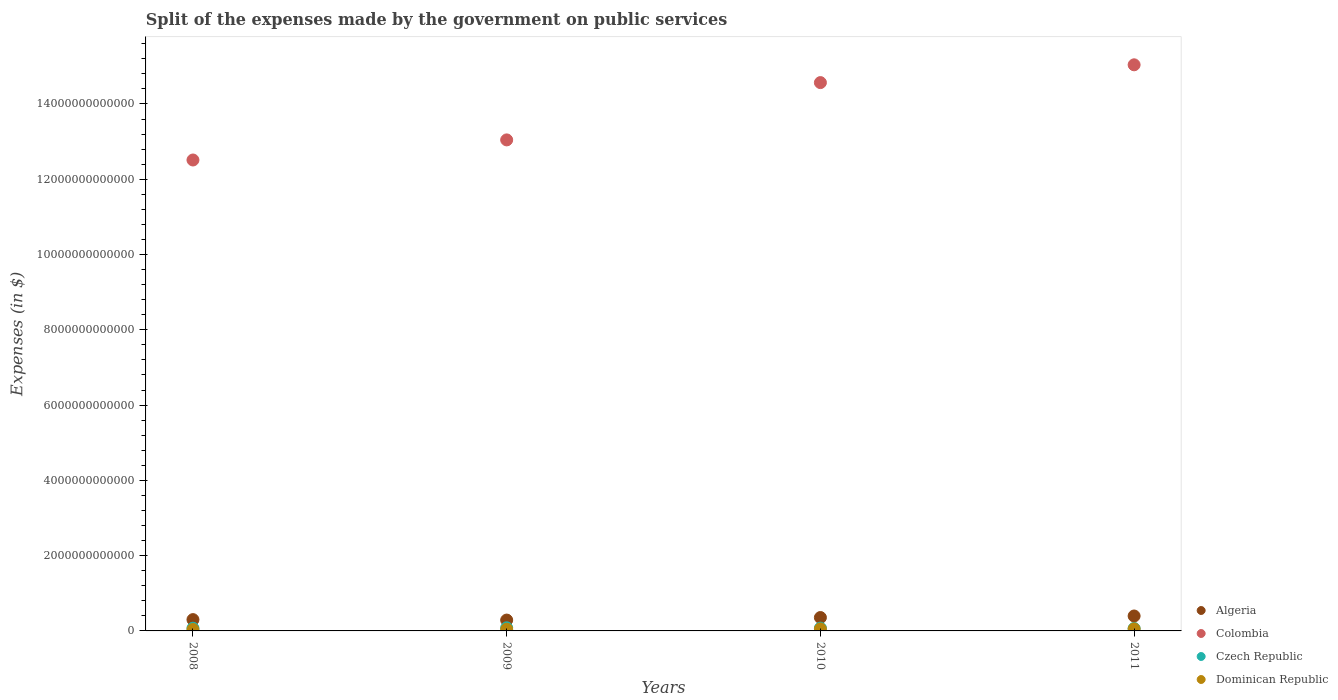How many different coloured dotlines are there?
Make the answer very short. 4. What is the expenses made by the government on public services in Dominican Republic in 2011?
Your answer should be compact. 5.39e+1. Across all years, what is the maximum expenses made by the government on public services in Algeria?
Your answer should be compact. 3.97e+11. Across all years, what is the minimum expenses made by the government on public services in Czech Republic?
Make the answer very short. 6.49e+1. What is the total expenses made by the government on public services in Czech Republic in the graph?
Offer a terse response. 2.95e+11. What is the difference between the expenses made by the government on public services in Colombia in 2008 and that in 2010?
Offer a terse response. -2.06e+12. What is the difference between the expenses made by the government on public services in Algeria in 2011 and the expenses made by the government on public services in Dominican Republic in 2010?
Provide a short and direct response. 3.44e+11. What is the average expenses made by the government on public services in Colombia per year?
Your answer should be compact. 1.38e+13. In the year 2009, what is the difference between the expenses made by the government on public services in Algeria and expenses made by the government on public services in Czech Republic?
Provide a succinct answer. 2.05e+11. What is the ratio of the expenses made by the government on public services in Colombia in 2009 to that in 2010?
Give a very brief answer. 0.9. What is the difference between the highest and the second highest expenses made by the government on public services in Algeria?
Your answer should be very brief. 4.10e+1. What is the difference between the highest and the lowest expenses made by the government on public services in Dominican Republic?
Offer a terse response. 1.66e+1. In how many years, is the expenses made by the government on public services in Colombia greater than the average expenses made by the government on public services in Colombia taken over all years?
Provide a succinct answer. 2. Is the sum of the expenses made by the government on public services in Algeria in 2008 and 2009 greater than the maximum expenses made by the government on public services in Colombia across all years?
Your answer should be very brief. No. Is it the case that in every year, the sum of the expenses made by the government on public services in Algeria and expenses made by the government on public services in Czech Republic  is greater than the sum of expenses made by the government on public services in Colombia and expenses made by the government on public services in Dominican Republic?
Offer a terse response. Yes. Is it the case that in every year, the sum of the expenses made by the government on public services in Dominican Republic and expenses made by the government on public services in Algeria  is greater than the expenses made by the government on public services in Colombia?
Ensure brevity in your answer.  No. Is the expenses made by the government on public services in Czech Republic strictly less than the expenses made by the government on public services in Dominican Republic over the years?
Your answer should be very brief. No. How many dotlines are there?
Your answer should be compact. 4. How many years are there in the graph?
Make the answer very short. 4. What is the difference between two consecutive major ticks on the Y-axis?
Your answer should be very brief. 2.00e+12. Does the graph contain grids?
Provide a short and direct response. No. How are the legend labels stacked?
Make the answer very short. Vertical. What is the title of the graph?
Give a very brief answer. Split of the expenses made by the government on public services. What is the label or title of the X-axis?
Offer a terse response. Years. What is the label or title of the Y-axis?
Provide a short and direct response. Expenses (in $). What is the Expenses (in $) in Algeria in 2008?
Your answer should be compact. 3.00e+11. What is the Expenses (in $) in Colombia in 2008?
Offer a terse response. 1.25e+13. What is the Expenses (in $) in Czech Republic in 2008?
Offer a terse response. 7.24e+1. What is the Expenses (in $) of Dominican Republic in 2008?
Offer a very short reply. 3.73e+1. What is the Expenses (in $) of Algeria in 2009?
Provide a succinct answer. 2.88e+11. What is the Expenses (in $) in Colombia in 2009?
Provide a succinct answer. 1.30e+13. What is the Expenses (in $) in Czech Republic in 2009?
Give a very brief answer. 8.32e+1. What is the Expenses (in $) of Dominican Republic in 2009?
Offer a very short reply. 4.52e+1. What is the Expenses (in $) in Algeria in 2010?
Offer a very short reply. 3.56e+11. What is the Expenses (in $) of Colombia in 2010?
Make the answer very short. 1.46e+13. What is the Expenses (in $) in Czech Republic in 2010?
Offer a terse response. 7.45e+1. What is the Expenses (in $) of Dominican Republic in 2010?
Provide a short and direct response. 5.28e+1. What is the Expenses (in $) in Algeria in 2011?
Offer a very short reply. 3.97e+11. What is the Expenses (in $) of Colombia in 2011?
Make the answer very short. 1.50e+13. What is the Expenses (in $) of Czech Republic in 2011?
Your answer should be very brief. 6.49e+1. What is the Expenses (in $) of Dominican Republic in 2011?
Make the answer very short. 5.39e+1. Across all years, what is the maximum Expenses (in $) in Algeria?
Offer a very short reply. 3.97e+11. Across all years, what is the maximum Expenses (in $) of Colombia?
Provide a short and direct response. 1.50e+13. Across all years, what is the maximum Expenses (in $) in Czech Republic?
Provide a short and direct response. 8.32e+1. Across all years, what is the maximum Expenses (in $) of Dominican Republic?
Provide a succinct answer. 5.39e+1. Across all years, what is the minimum Expenses (in $) of Algeria?
Your answer should be very brief. 2.88e+11. Across all years, what is the minimum Expenses (in $) of Colombia?
Ensure brevity in your answer.  1.25e+13. Across all years, what is the minimum Expenses (in $) in Czech Republic?
Make the answer very short. 6.49e+1. Across all years, what is the minimum Expenses (in $) in Dominican Republic?
Provide a short and direct response. 3.73e+1. What is the total Expenses (in $) in Algeria in the graph?
Provide a succinct answer. 1.34e+12. What is the total Expenses (in $) of Colombia in the graph?
Offer a very short reply. 5.52e+13. What is the total Expenses (in $) of Czech Republic in the graph?
Offer a very short reply. 2.95e+11. What is the total Expenses (in $) of Dominican Republic in the graph?
Make the answer very short. 1.89e+11. What is the difference between the Expenses (in $) of Algeria in 2008 and that in 2009?
Your response must be concise. 1.22e+1. What is the difference between the Expenses (in $) in Colombia in 2008 and that in 2009?
Offer a very short reply. -5.34e+11. What is the difference between the Expenses (in $) of Czech Republic in 2008 and that in 2009?
Make the answer very short. -1.07e+1. What is the difference between the Expenses (in $) in Dominican Republic in 2008 and that in 2009?
Make the answer very short. -7.91e+09. What is the difference between the Expenses (in $) of Algeria in 2008 and that in 2010?
Provide a short and direct response. -5.53e+1. What is the difference between the Expenses (in $) in Colombia in 2008 and that in 2010?
Ensure brevity in your answer.  -2.06e+12. What is the difference between the Expenses (in $) of Czech Republic in 2008 and that in 2010?
Your response must be concise. -2.06e+09. What is the difference between the Expenses (in $) in Dominican Republic in 2008 and that in 2010?
Keep it short and to the point. -1.56e+1. What is the difference between the Expenses (in $) of Algeria in 2008 and that in 2011?
Give a very brief answer. -9.63e+1. What is the difference between the Expenses (in $) in Colombia in 2008 and that in 2011?
Offer a very short reply. -2.53e+12. What is the difference between the Expenses (in $) in Czech Republic in 2008 and that in 2011?
Ensure brevity in your answer.  7.52e+09. What is the difference between the Expenses (in $) of Dominican Republic in 2008 and that in 2011?
Provide a succinct answer. -1.66e+1. What is the difference between the Expenses (in $) in Algeria in 2009 and that in 2010?
Offer a very short reply. -6.74e+1. What is the difference between the Expenses (in $) in Colombia in 2009 and that in 2010?
Provide a short and direct response. -1.52e+12. What is the difference between the Expenses (in $) of Czech Republic in 2009 and that in 2010?
Ensure brevity in your answer.  8.68e+09. What is the difference between the Expenses (in $) in Dominican Republic in 2009 and that in 2010?
Offer a very short reply. -7.65e+09. What is the difference between the Expenses (in $) of Algeria in 2009 and that in 2011?
Your answer should be very brief. -1.08e+11. What is the difference between the Expenses (in $) in Colombia in 2009 and that in 2011?
Make the answer very short. -1.99e+12. What is the difference between the Expenses (in $) in Czech Republic in 2009 and that in 2011?
Offer a terse response. 1.83e+1. What is the difference between the Expenses (in $) of Dominican Republic in 2009 and that in 2011?
Make the answer very short. -8.70e+09. What is the difference between the Expenses (in $) of Algeria in 2010 and that in 2011?
Give a very brief answer. -4.10e+1. What is the difference between the Expenses (in $) in Colombia in 2010 and that in 2011?
Your answer should be very brief. -4.73e+11. What is the difference between the Expenses (in $) in Czech Republic in 2010 and that in 2011?
Your answer should be compact. 9.58e+09. What is the difference between the Expenses (in $) in Dominican Republic in 2010 and that in 2011?
Provide a succinct answer. -1.04e+09. What is the difference between the Expenses (in $) of Algeria in 2008 and the Expenses (in $) of Colombia in 2009?
Keep it short and to the point. -1.27e+13. What is the difference between the Expenses (in $) in Algeria in 2008 and the Expenses (in $) in Czech Republic in 2009?
Make the answer very short. 2.17e+11. What is the difference between the Expenses (in $) of Algeria in 2008 and the Expenses (in $) of Dominican Republic in 2009?
Give a very brief answer. 2.55e+11. What is the difference between the Expenses (in $) of Colombia in 2008 and the Expenses (in $) of Czech Republic in 2009?
Your response must be concise. 1.24e+13. What is the difference between the Expenses (in $) of Colombia in 2008 and the Expenses (in $) of Dominican Republic in 2009?
Give a very brief answer. 1.25e+13. What is the difference between the Expenses (in $) of Czech Republic in 2008 and the Expenses (in $) of Dominican Republic in 2009?
Offer a very short reply. 2.72e+1. What is the difference between the Expenses (in $) in Algeria in 2008 and the Expenses (in $) in Colombia in 2010?
Keep it short and to the point. -1.43e+13. What is the difference between the Expenses (in $) in Algeria in 2008 and the Expenses (in $) in Czech Republic in 2010?
Provide a short and direct response. 2.26e+11. What is the difference between the Expenses (in $) of Algeria in 2008 and the Expenses (in $) of Dominican Republic in 2010?
Ensure brevity in your answer.  2.48e+11. What is the difference between the Expenses (in $) of Colombia in 2008 and the Expenses (in $) of Czech Republic in 2010?
Your response must be concise. 1.24e+13. What is the difference between the Expenses (in $) in Colombia in 2008 and the Expenses (in $) in Dominican Republic in 2010?
Ensure brevity in your answer.  1.25e+13. What is the difference between the Expenses (in $) of Czech Republic in 2008 and the Expenses (in $) of Dominican Republic in 2010?
Give a very brief answer. 1.96e+1. What is the difference between the Expenses (in $) in Algeria in 2008 and the Expenses (in $) in Colombia in 2011?
Offer a terse response. -1.47e+13. What is the difference between the Expenses (in $) in Algeria in 2008 and the Expenses (in $) in Czech Republic in 2011?
Offer a very short reply. 2.36e+11. What is the difference between the Expenses (in $) of Algeria in 2008 and the Expenses (in $) of Dominican Republic in 2011?
Make the answer very short. 2.47e+11. What is the difference between the Expenses (in $) in Colombia in 2008 and the Expenses (in $) in Czech Republic in 2011?
Give a very brief answer. 1.24e+13. What is the difference between the Expenses (in $) of Colombia in 2008 and the Expenses (in $) of Dominican Republic in 2011?
Your answer should be very brief. 1.25e+13. What is the difference between the Expenses (in $) of Czech Republic in 2008 and the Expenses (in $) of Dominican Republic in 2011?
Give a very brief answer. 1.85e+1. What is the difference between the Expenses (in $) of Algeria in 2009 and the Expenses (in $) of Colombia in 2010?
Make the answer very short. -1.43e+13. What is the difference between the Expenses (in $) of Algeria in 2009 and the Expenses (in $) of Czech Republic in 2010?
Keep it short and to the point. 2.14e+11. What is the difference between the Expenses (in $) of Algeria in 2009 and the Expenses (in $) of Dominican Republic in 2010?
Make the answer very short. 2.35e+11. What is the difference between the Expenses (in $) in Colombia in 2009 and the Expenses (in $) in Czech Republic in 2010?
Ensure brevity in your answer.  1.30e+13. What is the difference between the Expenses (in $) of Colombia in 2009 and the Expenses (in $) of Dominican Republic in 2010?
Offer a terse response. 1.30e+13. What is the difference between the Expenses (in $) in Czech Republic in 2009 and the Expenses (in $) in Dominican Republic in 2010?
Your answer should be compact. 3.03e+1. What is the difference between the Expenses (in $) in Algeria in 2009 and the Expenses (in $) in Colombia in 2011?
Give a very brief answer. -1.48e+13. What is the difference between the Expenses (in $) in Algeria in 2009 and the Expenses (in $) in Czech Republic in 2011?
Give a very brief answer. 2.23e+11. What is the difference between the Expenses (in $) of Algeria in 2009 and the Expenses (in $) of Dominican Republic in 2011?
Your answer should be very brief. 2.34e+11. What is the difference between the Expenses (in $) of Colombia in 2009 and the Expenses (in $) of Czech Republic in 2011?
Offer a very short reply. 1.30e+13. What is the difference between the Expenses (in $) in Colombia in 2009 and the Expenses (in $) in Dominican Republic in 2011?
Keep it short and to the point. 1.30e+13. What is the difference between the Expenses (in $) in Czech Republic in 2009 and the Expenses (in $) in Dominican Republic in 2011?
Make the answer very short. 2.93e+1. What is the difference between the Expenses (in $) in Algeria in 2010 and the Expenses (in $) in Colombia in 2011?
Provide a succinct answer. -1.47e+13. What is the difference between the Expenses (in $) in Algeria in 2010 and the Expenses (in $) in Czech Republic in 2011?
Offer a terse response. 2.91e+11. What is the difference between the Expenses (in $) in Algeria in 2010 and the Expenses (in $) in Dominican Republic in 2011?
Your answer should be very brief. 3.02e+11. What is the difference between the Expenses (in $) in Colombia in 2010 and the Expenses (in $) in Czech Republic in 2011?
Your response must be concise. 1.45e+13. What is the difference between the Expenses (in $) of Colombia in 2010 and the Expenses (in $) of Dominican Republic in 2011?
Ensure brevity in your answer.  1.45e+13. What is the difference between the Expenses (in $) in Czech Republic in 2010 and the Expenses (in $) in Dominican Republic in 2011?
Offer a terse response. 2.06e+1. What is the average Expenses (in $) in Algeria per year?
Provide a succinct answer. 3.35e+11. What is the average Expenses (in $) in Colombia per year?
Make the answer very short. 1.38e+13. What is the average Expenses (in $) of Czech Republic per year?
Offer a very short reply. 7.37e+1. What is the average Expenses (in $) of Dominican Republic per year?
Give a very brief answer. 4.73e+1. In the year 2008, what is the difference between the Expenses (in $) in Algeria and Expenses (in $) in Colombia?
Offer a very short reply. -1.22e+13. In the year 2008, what is the difference between the Expenses (in $) in Algeria and Expenses (in $) in Czech Republic?
Your response must be concise. 2.28e+11. In the year 2008, what is the difference between the Expenses (in $) in Algeria and Expenses (in $) in Dominican Republic?
Offer a very short reply. 2.63e+11. In the year 2008, what is the difference between the Expenses (in $) of Colombia and Expenses (in $) of Czech Republic?
Make the answer very short. 1.24e+13. In the year 2008, what is the difference between the Expenses (in $) of Colombia and Expenses (in $) of Dominican Republic?
Your response must be concise. 1.25e+13. In the year 2008, what is the difference between the Expenses (in $) in Czech Republic and Expenses (in $) in Dominican Republic?
Ensure brevity in your answer.  3.51e+1. In the year 2009, what is the difference between the Expenses (in $) of Algeria and Expenses (in $) of Colombia?
Keep it short and to the point. -1.28e+13. In the year 2009, what is the difference between the Expenses (in $) in Algeria and Expenses (in $) in Czech Republic?
Ensure brevity in your answer.  2.05e+11. In the year 2009, what is the difference between the Expenses (in $) of Algeria and Expenses (in $) of Dominican Republic?
Your answer should be very brief. 2.43e+11. In the year 2009, what is the difference between the Expenses (in $) of Colombia and Expenses (in $) of Czech Republic?
Your answer should be compact. 1.30e+13. In the year 2009, what is the difference between the Expenses (in $) in Colombia and Expenses (in $) in Dominican Republic?
Offer a very short reply. 1.30e+13. In the year 2009, what is the difference between the Expenses (in $) in Czech Republic and Expenses (in $) in Dominican Republic?
Ensure brevity in your answer.  3.80e+1. In the year 2010, what is the difference between the Expenses (in $) in Algeria and Expenses (in $) in Colombia?
Your response must be concise. -1.42e+13. In the year 2010, what is the difference between the Expenses (in $) of Algeria and Expenses (in $) of Czech Republic?
Offer a very short reply. 2.81e+11. In the year 2010, what is the difference between the Expenses (in $) of Algeria and Expenses (in $) of Dominican Republic?
Give a very brief answer. 3.03e+11. In the year 2010, what is the difference between the Expenses (in $) in Colombia and Expenses (in $) in Czech Republic?
Your answer should be compact. 1.45e+13. In the year 2010, what is the difference between the Expenses (in $) of Colombia and Expenses (in $) of Dominican Republic?
Provide a succinct answer. 1.45e+13. In the year 2010, what is the difference between the Expenses (in $) in Czech Republic and Expenses (in $) in Dominican Republic?
Ensure brevity in your answer.  2.16e+1. In the year 2011, what is the difference between the Expenses (in $) in Algeria and Expenses (in $) in Colombia?
Your answer should be very brief. -1.46e+13. In the year 2011, what is the difference between the Expenses (in $) of Algeria and Expenses (in $) of Czech Republic?
Keep it short and to the point. 3.32e+11. In the year 2011, what is the difference between the Expenses (in $) in Algeria and Expenses (in $) in Dominican Republic?
Ensure brevity in your answer.  3.43e+11. In the year 2011, what is the difference between the Expenses (in $) of Colombia and Expenses (in $) of Czech Republic?
Give a very brief answer. 1.50e+13. In the year 2011, what is the difference between the Expenses (in $) of Colombia and Expenses (in $) of Dominican Republic?
Your answer should be compact. 1.50e+13. In the year 2011, what is the difference between the Expenses (in $) in Czech Republic and Expenses (in $) in Dominican Republic?
Ensure brevity in your answer.  1.10e+1. What is the ratio of the Expenses (in $) in Algeria in 2008 to that in 2009?
Provide a succinct answer. 1.04. What is the ratio of the Expenses (in $) in Colombia in 2008 to that in 2009?
Your answer should be compact. 0.96. What is the ratio of the Expenses (in $) of Czech Republic in 2008 to that in 2009?
Provide a succinct answer. 0.87. What is the ratio of the Expenses (in $) of Dominican Republic in 2008 to that in 2009?
Ensure brevity in your answer.  0.82. What is the ratio of the Expenses (in $) of Algeria in 2008 to that in 2010?
Offer a terse response. 0.84. What is the ratio of the Expenses (in $) of Colombia in 2008 to that in 2010?
Offer a very short reply. 0.86. What is the ratio of the Expenses (in $) of Czech Republic in 2008 to that in 2010?
Your answer should be compact. 0.97. What is the ratio of the Expenses (in $) of Dominican Republic in 2008 to that in 2010?
Offer a very short reply. 0.71. What is the ratio of the Expenses (in $) in Algeria in 2008 to that in 2011?
Offer a very short reply. 0.76. What is the ratio of the Expenses (in $) of Colombia in 2008 to that in 2011?
Ensure brevity in your answer.  0.83. What is the ratio of the Expenses (in $) in Czech Republic in 2008 to that in 2011?
Give a very brief answer. 1.12. What is the ratio of the Expenses (in $) of Dominican Republic in 2008 to that in 2011?
Provide a short and direct response. 0.69. What is the ratio of the Expenses (in $) in Algeria in 2009 to that in 2010?
Provide a succinct answer. 0.81. What is the ratio of the Expenses (in $) of Colombia in 2009 to that in 2010?
Give a very brief answer. 0.9. What is the ratio of the Expenses (in $) in Czech Republic in 2009 to that in 2010?
Your answer should be compact. 1.12. What is the ratio of the Expenses (in $) in Dominican Republic in 2009 to that in 2010?
Give a very brief answer. 0.86. What is the ratio of the Expenses (in $) of Algeria in 2009 to that in 2011?
Your response must be concise. 0.73. What is the ratio of the Expenses (in $) in Colombia in 2009 to that in 2011?
Ensure brevity in your answer.  0.87. What is the ratio of the Expenses (in $) of Czech Republic in 2009 to that in 2011?
Give a very brief answer. 1.28. What is the ratio of the Expenses (in $) of Dominican Republic in 2009 to that in 2011?
Offer a very short reply. 0.84. What is the ratio of the Expenses (in $) of Algeria in 2010 to that in 2011?
Your answer should be very brief. 0.9. What is the ratio of the Expenses (in $) in Colombia in 2010 to that in 2011?
Provide a succinct answer. 0.97. What is the ratio of the Expenses (in $) in Czech Republic in 2010 to that in 2011?
Give a very brief answer. 1.15. What is the ratio of the Expenses (in $) of Dominican Republic in 2010 to that in 2011?
Offer a terse response. 0.98. What is the difference between the highest and the second highest Expenses (in $) in Algeria?
Keep it short and to the point. 4.10e+1. What is the difference between the highest and the second highest Expenses (in $) in Colombia?
Your answer should be compact. 4.73e+11. What is the difference between the highest and the second highest Expenses (in $) in Czech Republic?
Provide a short and direct response. 8.68e+09. What is the difference between the highest and the second highest Expenses (in $) of Dominican Republic?
Make the answer very short. 1.04e+09. What is the difference between the highest and the lowest Expenses (in $) in Algeria?
Ensure brevity in your answer.  1.08e+11. What is the difference between the highest and the lowest Expenses (in $) of Colombia?
Make the answer very short. 2.53e+12. What is the difference between the highest and the lowest Expenses (in $) in Czech Republic?
Provide a short and direct response. 1.83e+1. What is the difference between the highest and the lowest Expenses (in $) in Dominican Republic?
Your response must be concise. 1.66e+1. 